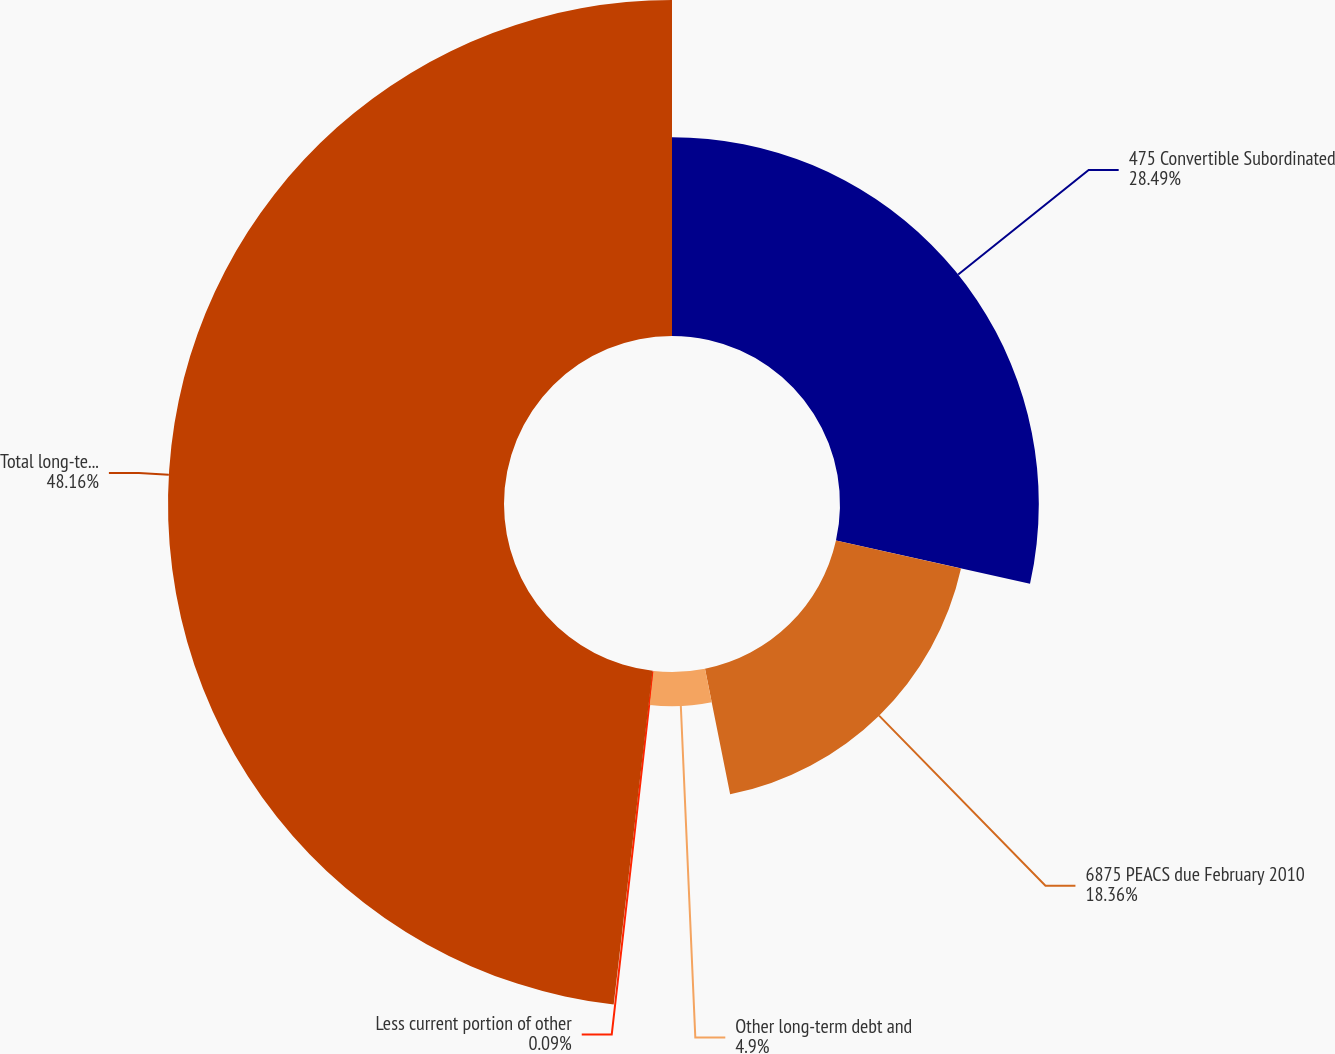Convert chart to OTSL. <chart><loc_0><loc_0><loc_500><loc_500><pie_chart><fcel>475 Convertible Subordinated<fcel>6875 PEACS due February 2010<fcel>Other long-term debt and<fcel>Less current portion of other<fcel>Total long-term debt and other<nl><fcel>28.49%<fcel>18.36%<fcel>4.9%<fcel>0.09%<fcel>48.15%<nl></chart> 